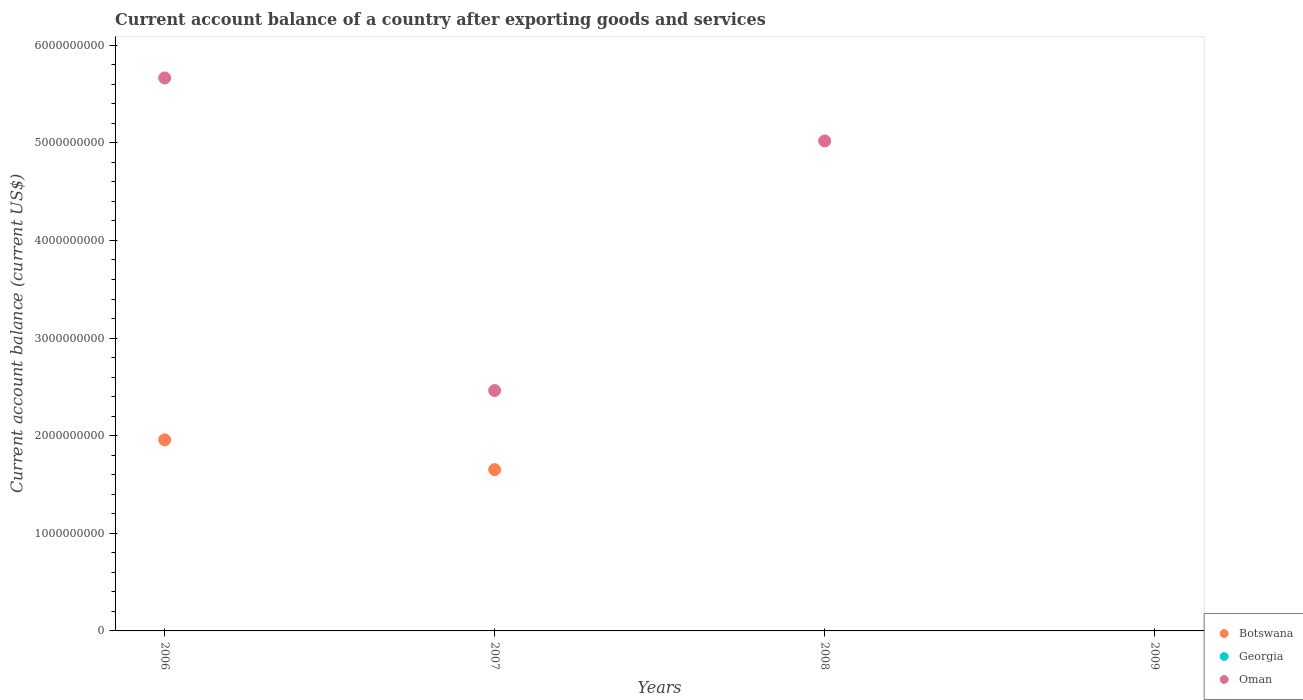How many different coloured dotlines are there?
Keep it short and to the point. 2. What is the account balance in Oman in 2008?
Offer a very short reply. 5.02e+09. Across all years, what is the maximum account balance in Oman?
Your answer should be compact. 5.66e+09. In which year was the account balance in Botswana maximum?
Offer a very short reply. 2006. What is the total account balance in Botswana in the graph?
Offer a very short reply. 3.61e+09. What is the difference between the account balance in Oman in 2006 and that in 2008?
Your response must be concise. 6.45e+08. What is the difference between the account balance in Georgia in 2006 and the account balance in Botswana in 2007?
Ensure brevity in your answer.  -1.65e+09. What is the average account balance in Botswana per year?
Offer a very short reply. 9.02e+08. In how many years, is the account balance in Botswana greater than 2400000000 US$?
Make the answer very short. 0. What is the ratio of the account balance in Oman in 2006 to that in 2008?
Offer a terse response. 1.13. Is the account balance in Oman in 2006 less than that in 2008?
Make the answer very short. No. What is the difference between the highest and the second highest account balance in Oman?
Your answer should be very brief. 6.45e+08. What is the difference between the highest and the lowest account balance in Oman?
Ensure brevity in your answer.  5.66e+09. Is the account balance in Georgia strictly less than the account balance in Botswana over the years?
Your response must be concise. Yes. How many dotlines are there?
Ensure brevity in your answer.  2. How many years are there in the graph?
Give a very brief answer. 4. What is the difference between two consecutive major ticks on the Y-axis?
Provide a short and direct response. 1.00e+09. Does the graph contain grids?
Keep it short and to the point. No. How are the legend labels stacked?
Offer a terse response. Vertical. What is the title of the graph?
Keep it short and to the point. Current account balance of a country after exporting goods and services. Does "Belarus" appear as one of the legend labels in the graph?
Your answer should be very brief. No. What is the label or title of the Y-axis?
Ensure brevity in your answer.  Current account balance (current US$). What is the Current account balance (current US$) of Botswana in 2006?
Your response must be concise. 1.96e+09. What is the Current account balance (current US$) in Oman in 2006?
Give a very brief answer. 5.66e+09. What is the Current account balance (current US$) of Botswana in 2007?
Offer a very short reply. 1.65e+09. What is the Current account balance (current US$) in Oman in 2007?
Offer a very short reply. 2.46e+09. What is the Current account balance (current US$) of Botswana in 2008?
Provide a short and direct response. 0. What is the Current account balance (current US$) in Georgia in 2008?
Your answer should be very brief. 0. What is the Current account balance (current US$) of Oman in 2008?
Keep it short and to the point. 5.02e+09. What is the Current account balance (current US$) of Botswana in 2009?
Your answer should be very brief. 0. What is the Current account balance (current US$) of Georgia in 2009?
Offer a very short reply. 0. Across all years, what is the maximum Current account balance (current US$) in Botswana?
Your answer should be compact. 1.96e+09. Across all years, what is the maximum Current account balance (current US$) of Oman?
Make the answer very short. 5.66e+09. Across all years, what is the minimum Current account balance (current US$) of Botswana?
Provide a short and direct response. 0. What is the total Current account balance (current US$) in Botswana in the graph?
Make the answer very short. 3.61e+09. What is the total Current account balance (current US$) in Oman in the graph?
Offer a terse response. 1.31e+1. What is the difference between the Current account balance (current US$) in Botswana in 2006 and that in 2007?
Provide a short and direct response. 3.05e+08. What is the difference between the Current account balance (current US$) of Oman in 2006 and that in 2007?
Provide a succinct answer. 3.20e+09. What is the difference between the Current account balance (current US$) in Oman in 2006 and that in 2008?
Offer a very short reply. 6.45e+08. What is the difference between the Current account balance (current US$) of Oman in 2007 and that in 2008?
Your answer should be very brief. -2.56e+09. What is the difference between the Current account balance (current US$) in Botswana in 2006 and the Current account balance (current US$) in Oman in 2007?
Make the answer very short. -5.05e+08. What is the difference between the Current account balance (current US$) in Botswana in 2006 and the Current account balance (current US$) in Oman in 2008?
Your answer should be very brief. -3.06e+09. What is the difference between the Current account balance (current US$) of Botswana in 2007 and the Current account balance (current US$) of Oman in 2008?
Give a very brief answer. -3.37e+09. What is the average Current account balance (current US$) in Botswana per year?
Offer a terse response. 9.02e+08. What is the average Current account balance (current US$) of Georgia per year?
Your answer should be compact. 0. What is the average Current account balance (current US$) of Oman per year?
Ensure brevity in your answer.  3.29e+09. In the year 2006, what is the difference between the Current account balance (current US$) in Botswana and Current account balance (current US$) in Oman?
Your answer should be compact. -3.71e+09. In the year 2007, what is the difference between the Current account balance (current US$) in Botswana and Current account balance (current US$) in Oman?
Offer a terse response. -8.10e+08. What is the ratio of the Current account balance (current US$) in Botswana in 2006 to that in 2007?
Ensure brevity in your answer.  1.18. What is the ratio of the Current account balance (current US$) of Oman in 2006 to that in 2007?
Give a very brief answer. 2.3. What is the ratio of the Current account balance (current US$) of Oman in 2006 to that in 2008?
Provide a succinct answer. 1.13. What is the ratio of the Current account balance (current US$) of Oman in 2007 to that in 2008?
Your answer should be compact. 0.49. What is the difference between the highest and the second highest Current account balance (current US$) in Oman?
Offer a very short reply. 6.45e+08. What is the difference between the highest and the lowest Current account balance (current US$) of Botswana?
Offer a terse response. 1.96e+09. What is the difference between the highest and the lowest Current account balance (current US$) of Oman?
Your answer should be very brief. 5.66e+09. 